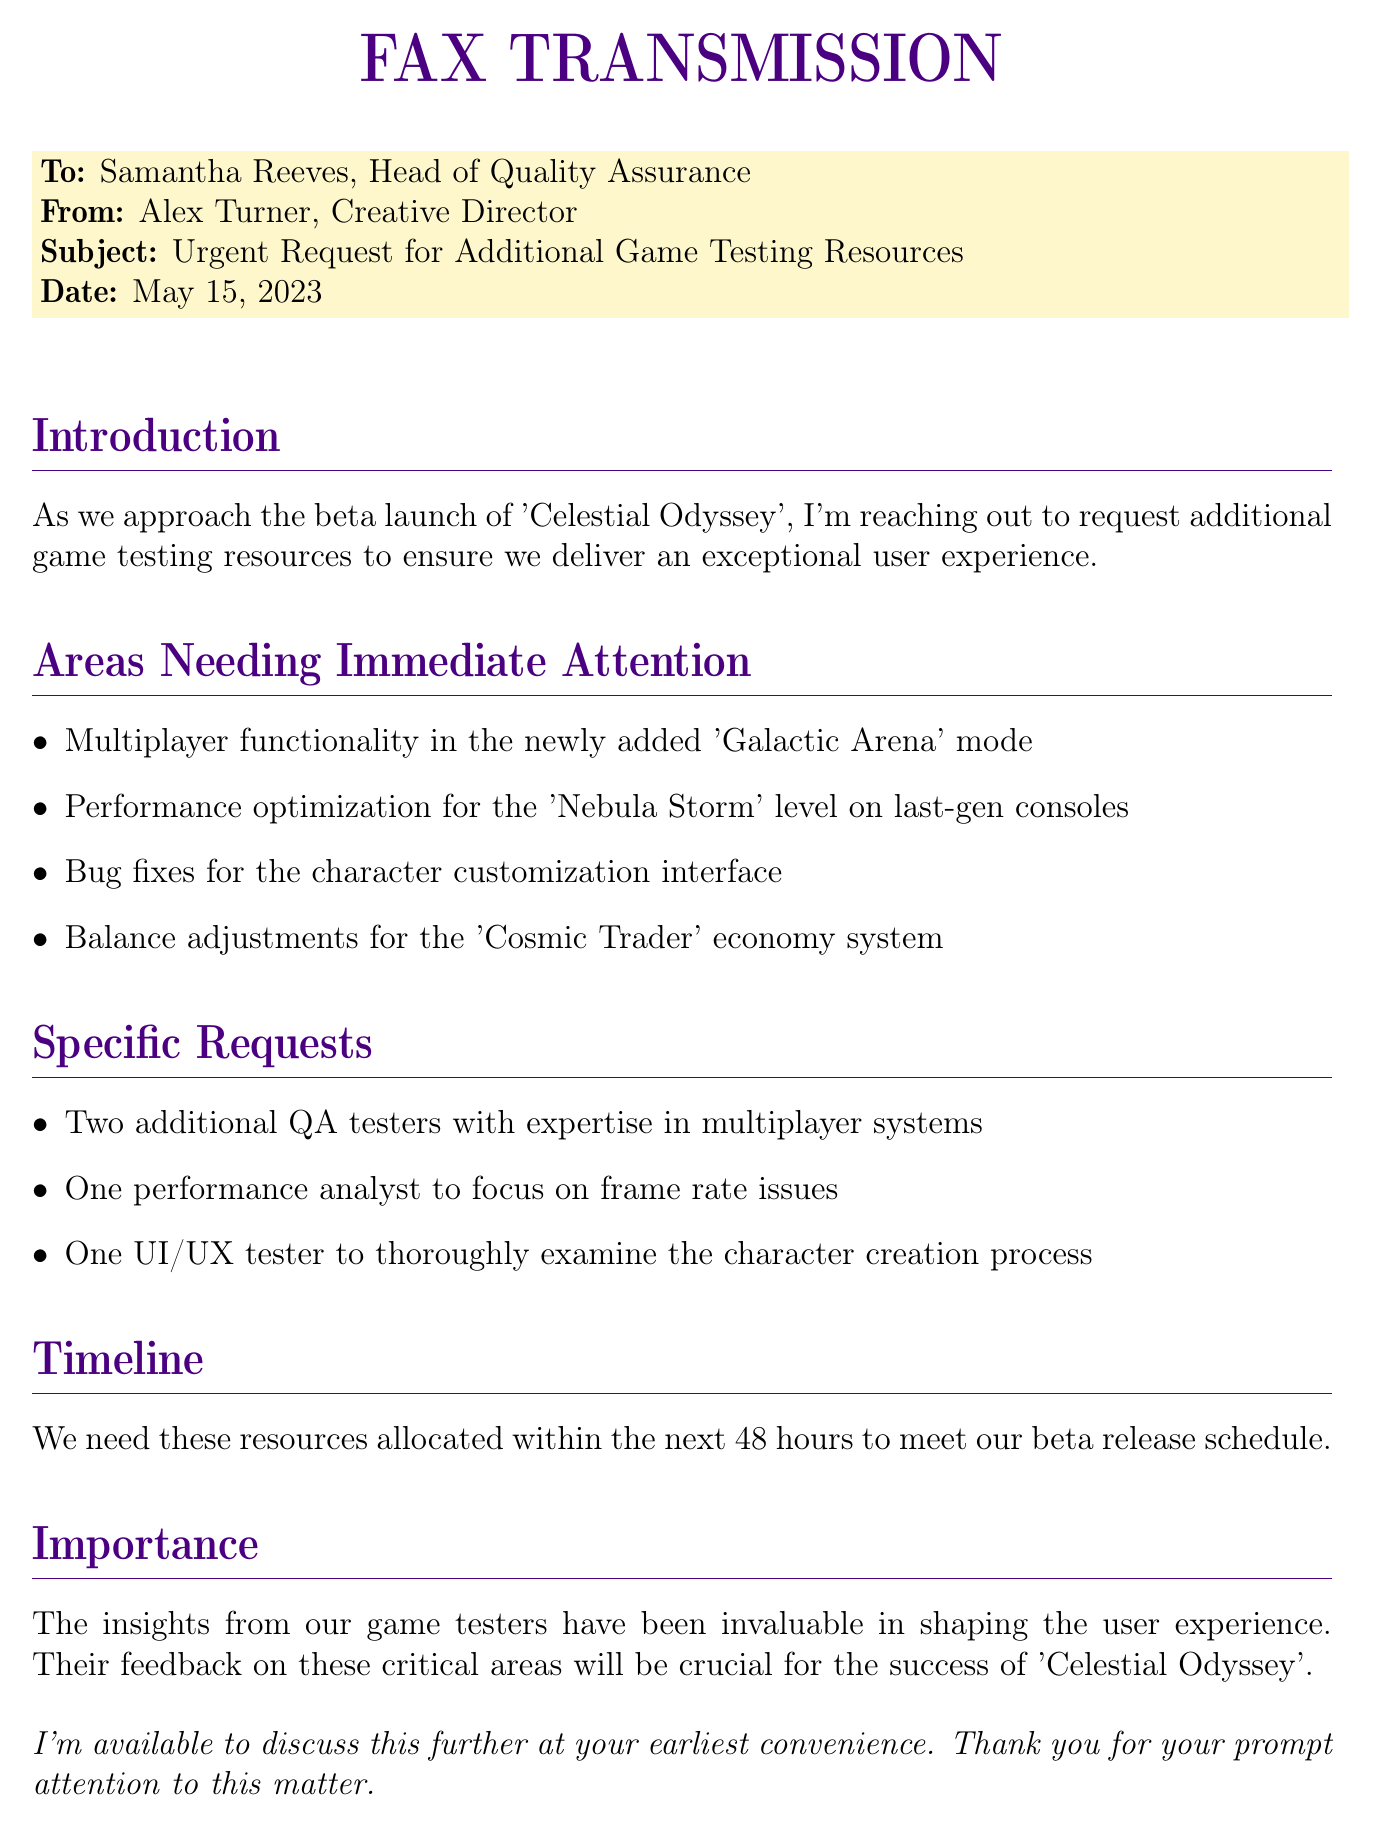What is the subject of the fax? The subject is explicitly stated in the document as "Urgent Request for Additional Game Testing Resources."
Answer: Urgent Request for Additional Game Testing Resources Who is the sender of the fax? The sender is identified in the document as "Alex Turner, Creative Director."
Answer: Alex Turner How many additional QA testers are requested? The specific request states the need for "Two additional QA testers with expertise in multiplayer systems."
Answer: Two What is the timeline for resource allocation? The document clearly mentions the need for resources to be allocated "within the next 48 hours."
Answer: 48 hours What game is referenced in the document? The game is mentioned as "Celestial Odyssey," which is the focus of the testing resources request.
Answer: Celestial Odyssey Which mode requires immediate testing attention? The document lists "Multiplayer functionality in the newly added 'Galactic Arena' mode" as an area needing attention.
Answer: Galactic Arena What role does the performance analyst focus on? The performance analyst is requested to focus on "frame rate issues" as mentioned in the specific requests.
Answer: frame rate issues What is the importance of the tester's insights according to the fax? The document states that the insights from game testers have been "invaluable in shaping the user experience."
Answer: invaluable How many areas needing immediate attention are listed? The document lists "four" specific areas that need immediate attention.
Answer: four What is the date of the fax? The date is clearly specified in the document as "May 15, 2023."
Answer: May 15, 2023 